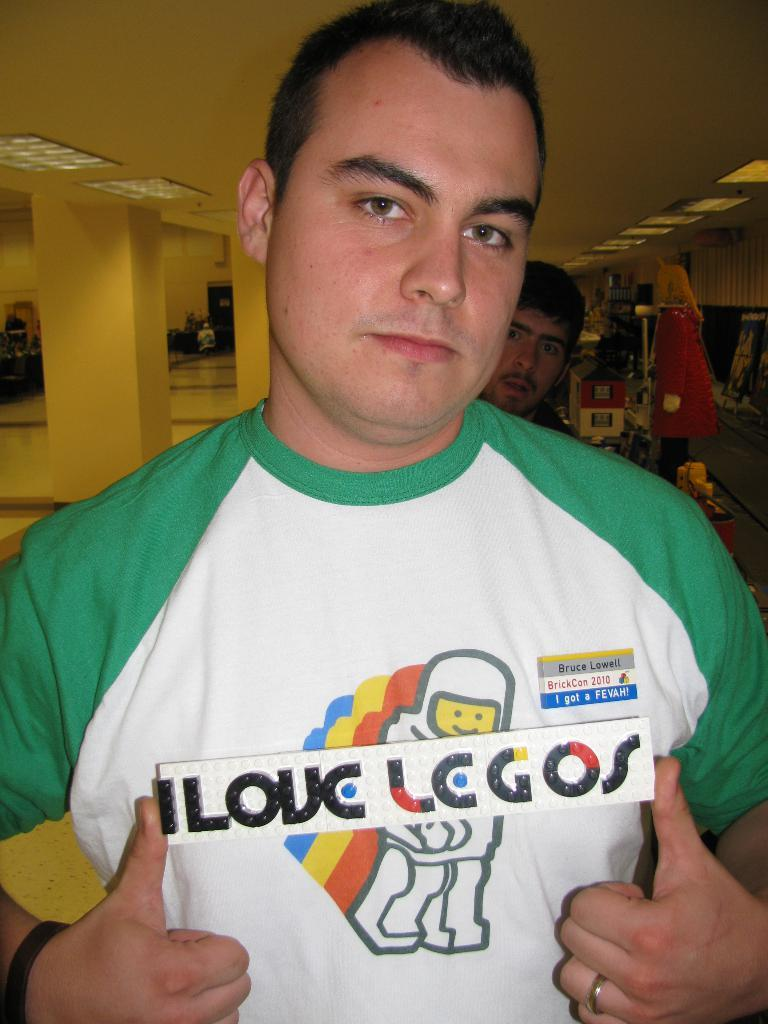<image>
Render a clear and concise summary of the photo. A man has a name tag on designating his name as Bruce. 